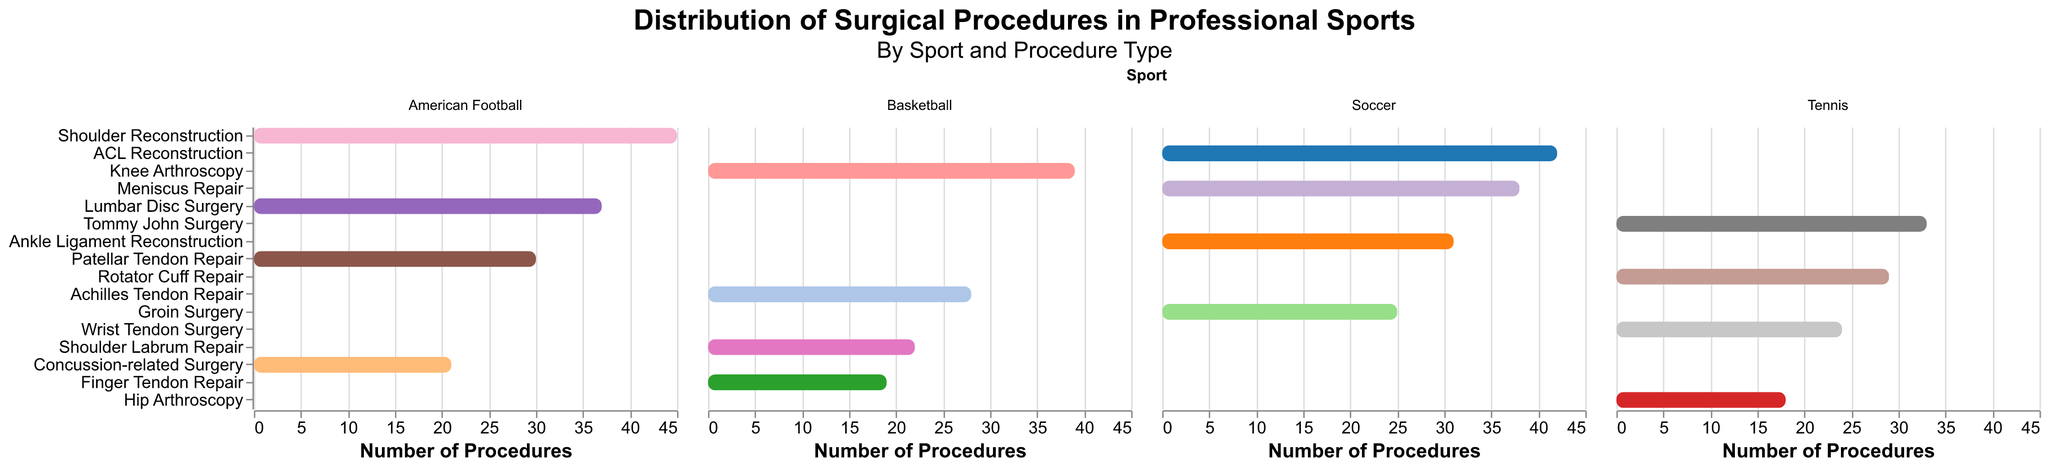Which sport has the highest number of a single type of surgical procedure? The sports are Soccer, Basketball, Tennis, and American Football. The highest count in any sport is observed in American Football for Shoulder Reconstruction with 45 procedures.
Answer: American Football Which procedures are the most frequent in Soccer and Basketball, respectively? For Soccer, ACL Reconstruction (42) is the most frequent. For Basketball, Knee Arthroscopy (39) is the most frequent procedure.
Answer: ACL Reconstruction in Soccer and Knee Arthroscopy in Basketball What is the total number of surgical procedures performed on Tennis players? Add the number of procedures for all the occurrences in Tennis: Tommy John Surgery (33), Rotator Cuff Repair (29), Wrist Tendon Surgery (24), and Hip Arthroscopy (18). The total is 33 + 29 + 24 + 18.
Answer: 104 Between Meniscus Repair in Soccer and Patellar Tendon Repair in American Football, which one has higher occurrences? Meniscus Repair in Soccer has a count of 38 while Patellar Tendon Repair in American Football has a count of 30. So, Meniscus Repair is more frequent.
Answer: Meniscus Repair in Soccer What is the combined count of Shoulder-related surgeries across all sports? Identify and sum up the counts of Shoulder Labrum Repair in Basketball (22), Shoulder Reconstruction in American Football (45). The total is 22 + 45.
Answer: 67 How many different types of procedures are performed on Soccer players? In the subplot for Soccer, count the distinct types of procedures listed: ACL Reconstruction, Meniscus Repair, Ankle Ligament Reconstruction, and Groin Surgery. There are 4 types.
Answer: 4 Which surgical procedure is performed the least number of times in Tennis? Within the Tennis subplot, Hip Arthroscopy has the lowest count of 18 among the procedures.
Answer: Hip Arthroscopy What is the difference in the number of Knee Arthroscopy procedures in Basketball and ACL Reconstruction procedures in Soccer? Knee Arthroscopy in Basketball has 39 procedures, and ACL Reconstruction in Soccer has 42 procedures. The difference is 42 - 39.
Answer: 3 What is the sum of all procedures performed in American Football? Add all the occurrences in American Football: Shoulder Reconstruction (45), Lumbar Disc Surgery (37), Patellar Tendon Repair (30), and Concussion-related Surgery (21). The total is 45 + 37 + 30 + 21.
Answer: 133 